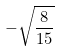<formula> <loc_0><loc_0><loc_500><loc_500>- \sqrt { \frac { 8 } { 1 5 } }</formula> 